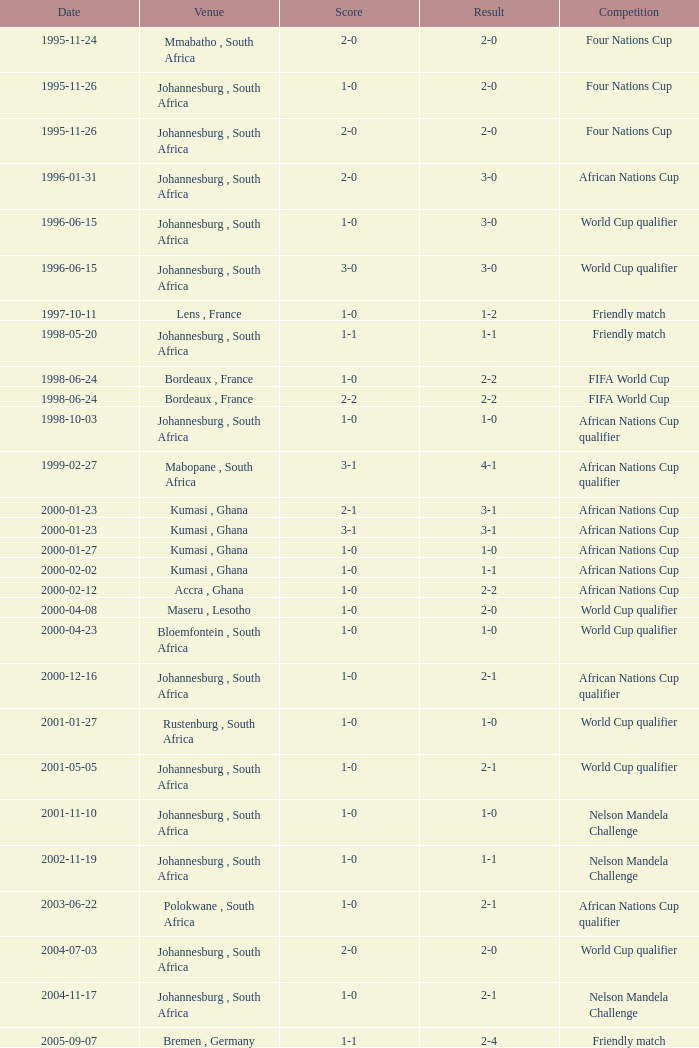What is the Date of the Fifa World Cup with a Score of 1-0? 1998-06-24. 